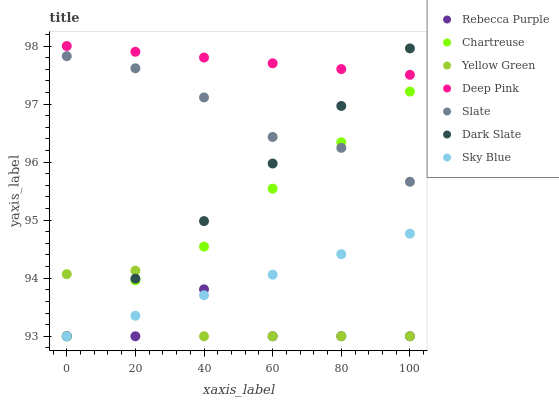Does Rebecca Purple have the minimum area under the curve?
Answer yes or no. Yes. Does Deep Pink have the maximum area under the curve?
Answer yes or no. Yes. Does Yellow Green have the minimum area under the curve?
Answer yes or no. No. Does Yellow Green have the maximum area under the curve?
Answer yes or no. No. Is Deep Pink the smoothest?
Answer yes or no. Yes. Is Rebecca Purple the roughest?
Answer yes or no. Yes. Is Yellow Green the smoothest?
Answer yes or no. No. Is Yellow Green the roughest?
Answer yes or no. No. Does Yellow Green have the lowest value?
Answer yes or no. Yes. Does Slate have the lowest value?
Answer yes or no. No. Does Deep Pink have the highest value?
Answer yes or no. Yes. Does Yellow Green have the highest value?
Answer yes or no. No. Is Slate less than Deep Pink?
Answer yes or no. Yes. Is Slate greater than Sky Blue?
Answer yes or no. Yes. Does Yellow Green intersect Dark Slate?
Answer yes or no. Yes. Is Yellow Green less than Dark Slate?
Answer yes or no. No. Is Yellow Green greater than Dark Slate?
Answer yes or no. No. Does Slate intersect Deep Pink?
Answer yes or no. No. 